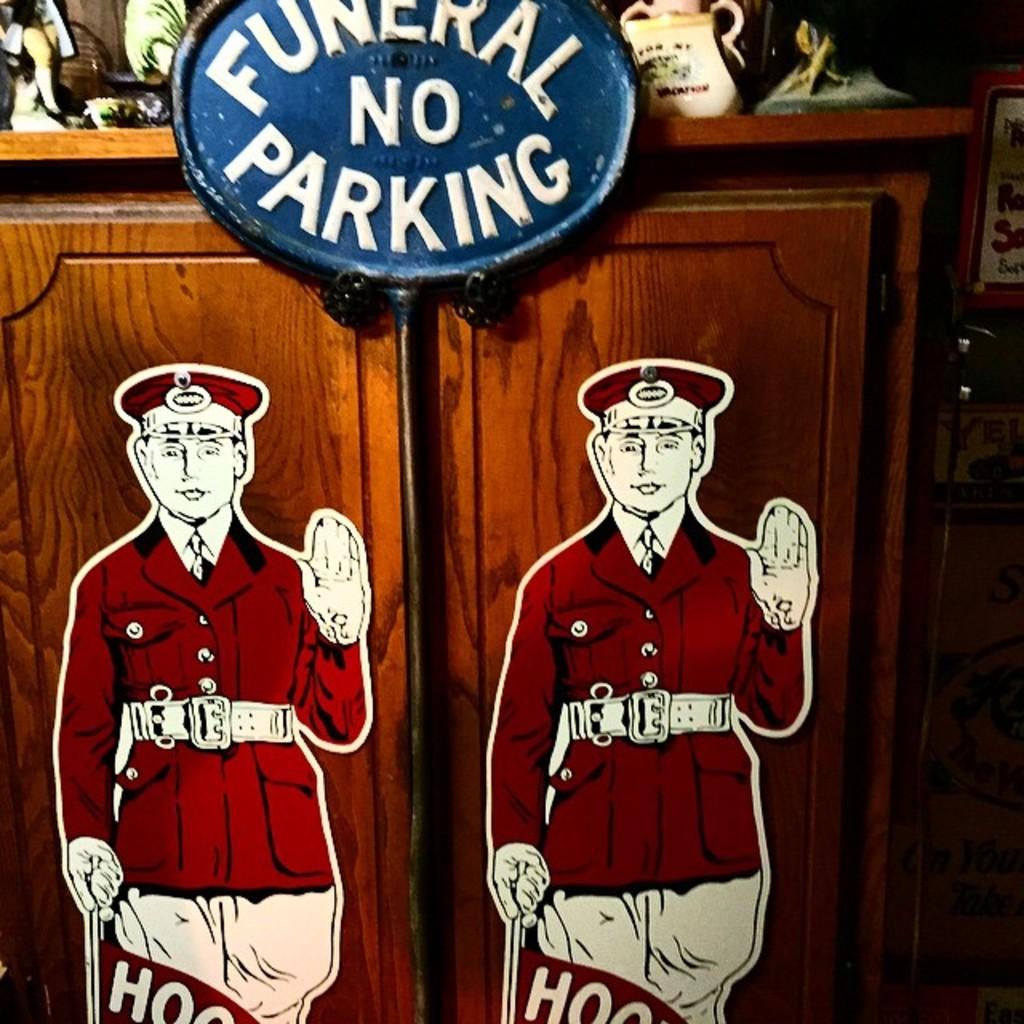What does the sign say?
Your response must be concise. Funeral no parking. Why is there no parking?
Your response must be concise. Funeral. 